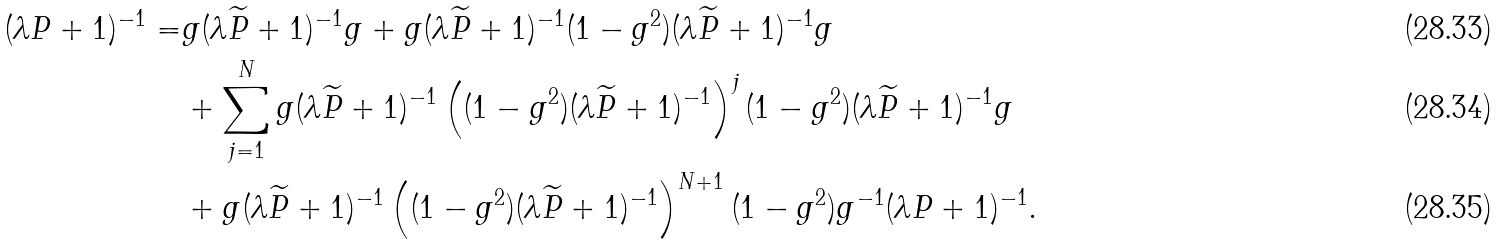Convert formula to latex. <formula><loc_0><loc_0><loc_500><loc_500>( \lambda P + 1 ) ^ { - 1 } = & g ( \lambda \widetilde { P } + 1 ) ^ { - 1 } g + g ( \lambda \widetilde { P } + 1 ) ^ { - 1 } ( 1 - g ^ { 2 } ) ( \lambda \widetilde { P } + 1 ) ^ { - 1 } g \\ & + \sum _ { j = 1 } ^ { N } g ( \lambda \widetilde { P } + 1 ) ^ { - 1 } \left ( ( 1 - g ^ { 2 } ) ( \lambda \widetilde { P } + 1 ) ^ { - 1 } \right ) ^ { j } ( 1 - g ^ { 2 } ) ( \lambda \widetilde { P } + 1 ) ^ { - 1 } g \\ & + g ( \lambda \widetilde { P } + 1 ) ^ { - 1 } \left ( ( 1 - g ^ { 2 } ) ( \lambda \widetilde { P } + 1 ) ^ { - 1 } \right ) ^ { N + 1 } ( 1 - g ^ { 2 } ) g ^ { - 1 } ( \lambda P + 1 ) ^ { - 1 } .</formula> 